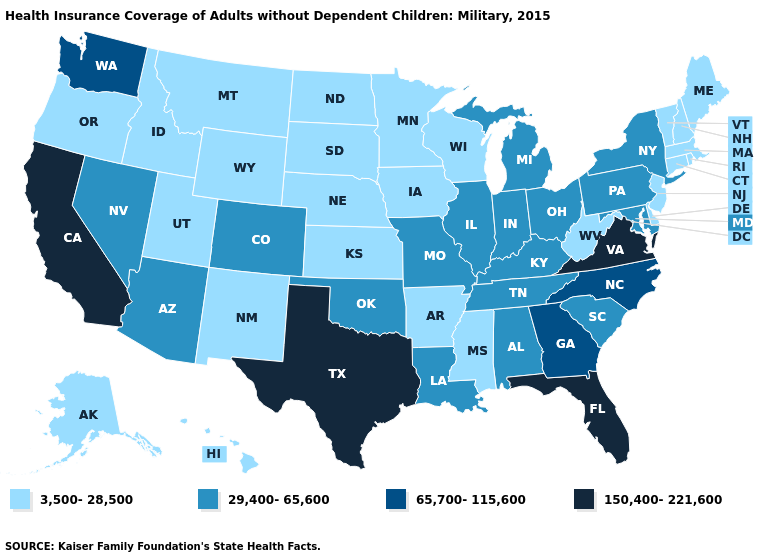Name the states that have a value in the range 29,400-65,600?
Keep it brief. Alabama, Arizona, Colorado, Illinois, Indiana, Kentucky, Louisiana, Maryland, Michigan, Missouri, Nevada, New York, Ohio, Oklahoma, Pennsylvania, South Carolina, Tennessee. What is the lowest value in the USA?
Concise answer only. 3,500-28,500. Does Michigan have a higher value than Illinois?
Keep it brief. No. Does New Jersey have the same value as Arkansas?
Give a very brief answer. Yes. Among the states that border Iowa , does Illinois have the highest value?
Short answer required. Yes. Among the states that border New York , does Pennsylvania have the highest value?
Answer briefly. Yes. Among the states that border Connecticut , which have the lowest value?
Answer briefly. Massachusetts, Rhode Island. What is the lowest value in the MidWest?
Quick response, please. 3,500-28,500. Name the states that have a value in the range 65,700-115,600?
Write a very short answer. Georgia, North Carolina, Washington. Which states have the lowest value in the USA?
Short answer required. Alaska, Arkansas, Connecticut, Delaware, Hawaii, Idaho, Iowa, Kansas, Maine, Massachusetts, Minnesota, Mississippi, Montana, Nebraska, New Hampshire, New Jersey, New Mexico, North Dakota, Oregon, Rhode Island, South Dakota, Utah, Vermont, West Virginia, Wisconsin, Wyoming. Name the states that have a value in the range 3,500-28,500?
Short answer required. Alaska, Arkansas, Connecticut, Delaware, Hawaii, Idaho, Iowa, Kansas, Maine, Massachusetts, Minnesota, Mississippi, Montana, Nebraska, New Hampshire, New Jersey, New Mexico, North Dakota, Oregon, Rhode Island, South Dakota, Utah, Vermont, West Virginia, Wisconsin, Wyoming. Which states have the lowest value in the Northeast?
Answer briefly. Connecticut, Maine, Massachusetts, New Hampshire, New Jersey, Rhode Island, Vermont. What is the highest value in the MidWest ?
Answer briefly. 29,400-65,600. Which states have the highest value in the USA?
Quick response, please. California, Florida, Texas, Virginia. Which states have the lowest value in the USA?
Concise answer only. Alaska, Arkansas, Connecticut, Delaware, Hawaii, Idaho, Iowa, Kansas, Maine, Massachusetts, Minnesota, Mississippi, Montana, Nebraska, New Hampshire, New Jersey, New Mexico, North Dakota, Oregon, Rhode Island, South Dakota, Utah, Vermont, West Virginia, Wisconsin, Wyoming. 